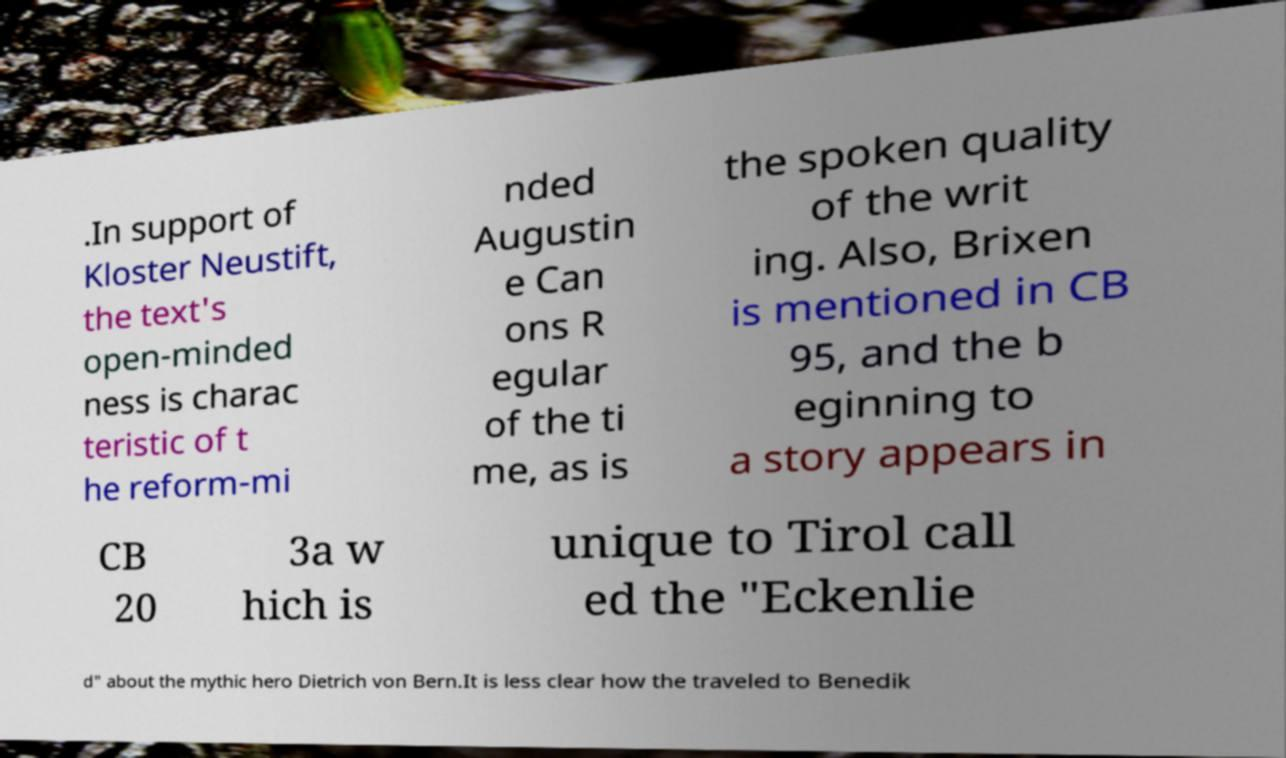Please identify and transcribe the text found in this image. .In support of Kloster Neustift, the text's open-minded ness is charac teristic of t he reform-mi nded Augustin e Can ons R egular of the ti me, as is the spoken quality of the writ ing. Also, Brixen is mentioned in CB 95, and the b eginning to a story appears in CB 20 3a w hich is unique to Tirol call ed the "Eckenlie d" about the mythic hero Dietrich von Bern.It is less clear how the traveled to Benedik 